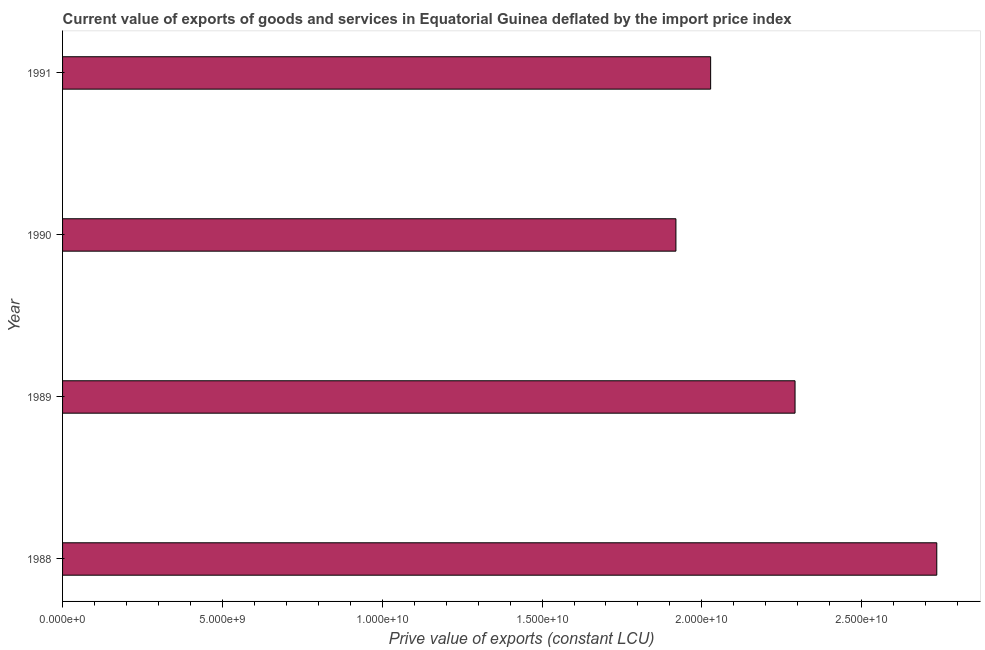What is the title of the graph?
Provide a succinct answer. Current value of exports of goods and services in Equatorial Guinea deflated by the import price index. What is the label or title of the X-axis?
Your response must be concise. Prive value of exports (constant LCU). What is the price value of exports in 1991?
Your answer should be compact. 2.03e+1. Across all years, what is the maximum price value of exports?
Give a very brief answer. 2.73e+1. Across all years, what is the minimum price value of exports?
Provide a short and direct response. 1.92e+1. In which year was the price value of exports maximum?
Ensure brevity in your answer.  1988. In which year was the price value of exports minimum?
Provide a succinct answer. 1990. What is the sum of the price value of exports?
Offer a very short reply. 8.97e+1. What is the difference between the price value of exports in 1988 and 1990?
Keep it short and to the point. 8.16e+09. What is the average price value of exports per year?
Give a very brief answer. 2.24e+1. What is the median price value of exports?
Ensure brevity in your answer.  2.16e+1. What is the ratio of the price value of exports in 1989 to that in 1990?
Ensure brevity in your answer.  1.19. Is the price value of exports in 1989 less than that in 1991?
Keep it short and to the point. No. Is the difference between the price value of exports in 1989 and 1991 greater than the difference between any two years?
Offer a terse response. No. What is the difference between the highest and the second highest price value of exports?
Your answer should be compact. 4.43e+09. Is the sum of the price value of exports in 1988 and 1989 greater than the maximum price value of exports across all years?
Your response must be concise. Yes. What is the difference between the highest and the lowest price value of exports?
Provide a short and direct response. 8.16e+09. In how many years, is the price value of exports greater than the average price value of exports taken over all years?
Provide a succinct answer. 2. Are all the bars in the graph horizontal?
Your answer should be very brief. Yes. How many years are there in the graph?
Your response must be concise. 4. What is the Prive value of exports (constant LCU) of 1988?
Provide a short and direct response. 2.73e+1. What is the Prive value of exports (constant LCU) in 1989?
Ensure brevity in your answer.  2.29e+1. What is the Prive value of exports (constant LCU) in 1990?
Provide a succinct answer. 1.92e+1. What is the Prive value of exports (constant LCU) in 1991?
Make the answer very short. 2.03e+1. What is the difference between the Prive value of exports (constant LCU) in 1988 and 1989?
Your response must be concise. 4.43e+09. What is the difference between the Prive value of exports (constant LCU) in 1988 and 1990?
Your answer should be compact. 8.16e+09. What is the difference between the Prive value of exports (constant LCU) in 1988 and 1991?
Give a very brief answer. 7.07e+09. What is the difference between the Prive value of exports (constant LCU) in 1989 and 1990?
Keep it short and to the point. 3.73e+09. What is the difference between the Prive value of exports (constant LCU) in 1989 and 1991?
Your answer should be compact. 2.64e+09. What is the difference between the Prive value of exports (constant LCU) in 1990 and 1991?
Make the answer very short. -1.09e+09. What is the ratio of the Prive value of exports (constant LCU) in 1988 to that in 1989?
Provide a short and direct response. 1.19. What is the ratio of the Prive value of exports (constant LCU) in 1988 to that in 1990?
Provide a succinct answer. 1.43. What is the ratio of the Prive value of exports (constant LCU) in 1988 to that in 1991?
Your answer should be compact. 1.35. What is the ratio of the Prive value of exports (constant LCU) in 1989 to that in 1990?
Provide a succinct answer. 1.19. What is the ratio of the Prive value of exports (constant LCU) in 1989 to that in 1991?
Provide a short and direct response. 1.13. What is the ratio of the Prive value of exports (constant LCU) in 1990 to that in 1991?
Provide a succinct answer. 0.95. 